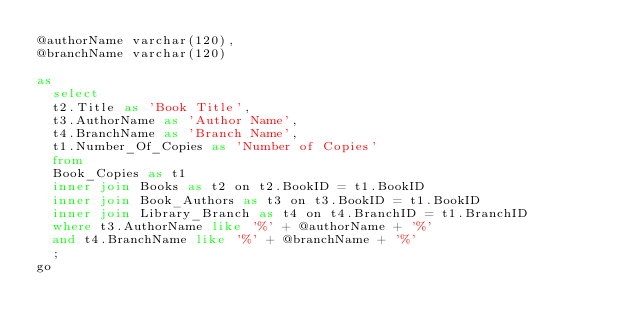Convert code to text. <code><loc_0><loc_0><loc_500><loc_500><_SQL_>@authorName varchar(120),
@branchName varchar(120)

as
	select
	t2.Title as 'Book Title',
	t3.AuthorName as 'Author Name',
	t4.BranchName as 'Branch Name',
	t1.Number_Of_Copies as 'Number of Copies'
	from
	Book_Copies as t1
	inner join Books as t2 on t2.BookID = t1.BookID
	inner join Book_Authors as t3 on t3.BookID = t1.BookID
	inner join Library_Branch as t4 on t4.BranchID = t1.BranchID
	where t3.AuthorName like '%' + @authorName + '%'
	and t4.BranchName like '%' + @branchName + '%'
	;
go</code> 